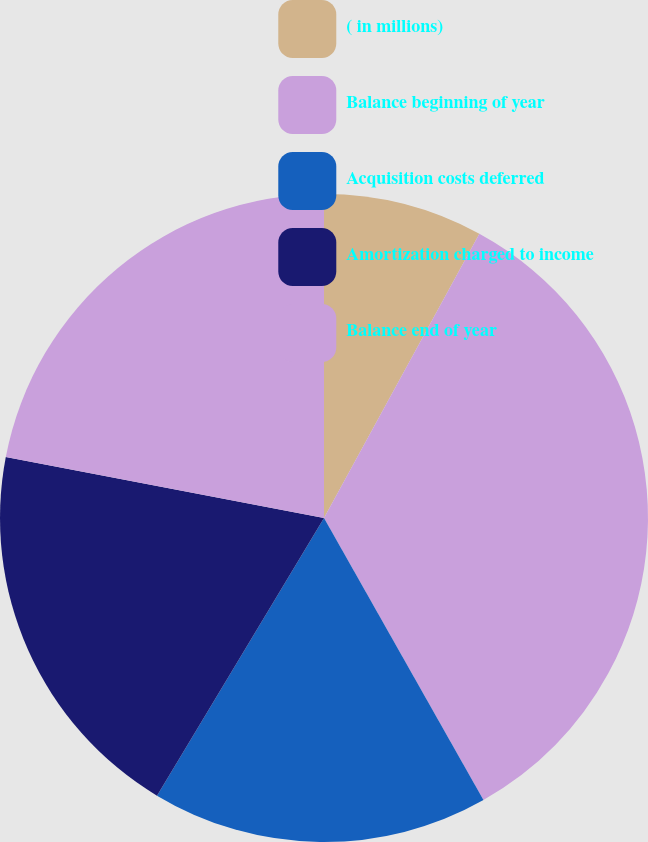Convert chart to OTSL. <chart><loc_0><loc_0><loc_500><loc_500><pie_chart><fcel>( in millions)<fcel>Balance beginning of year<fcel>Acquisition costs deferred<fcel>Amortization charged to income<fcel>Balance end of year<nl><fcel>7.96%<fcel>33.85%<fcel>16.81%<fcel>19.4%<fcel>21.98%<nl></chart> 